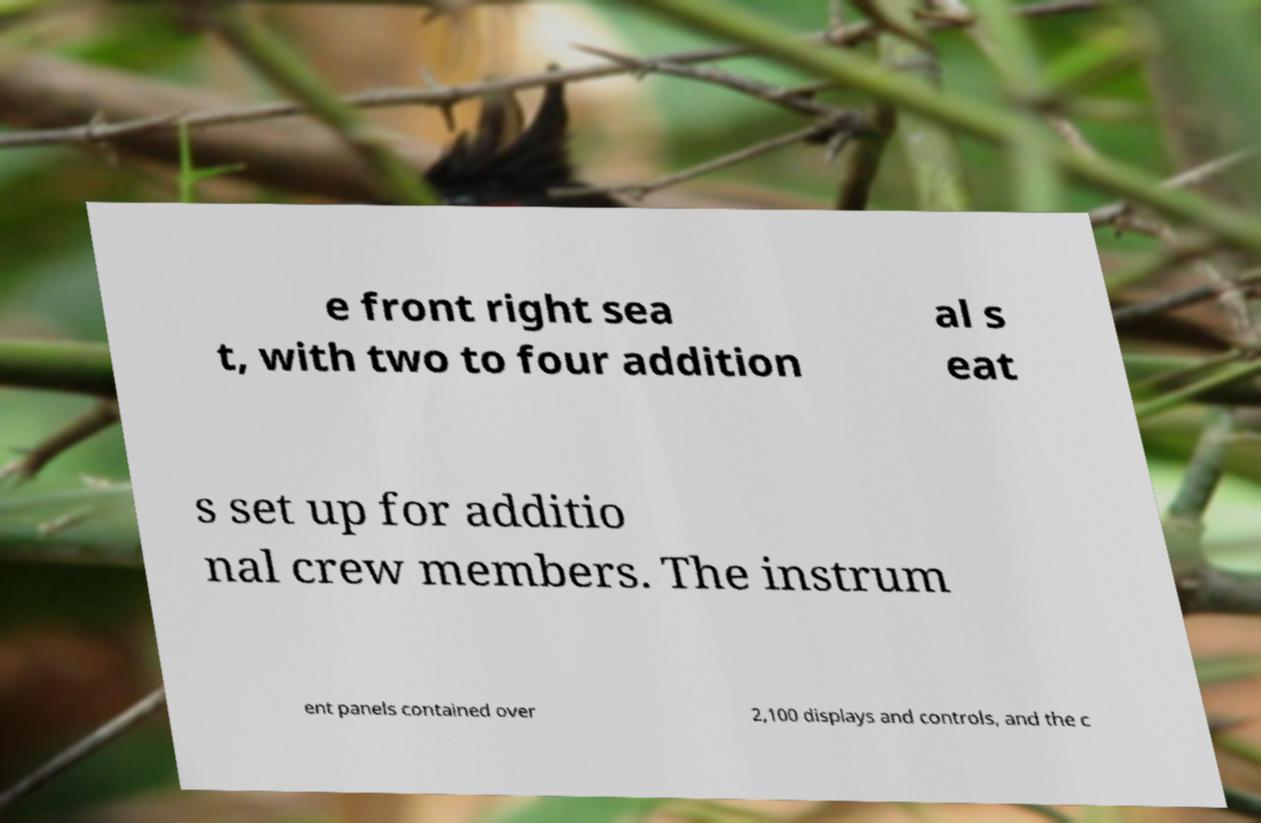Could you extract and type out the text from this image? e front right sea t, with two to four addition al s eat s set up for additio nal crew members. The instrum ent panels contained over 2,100 displays and controls, and the c 